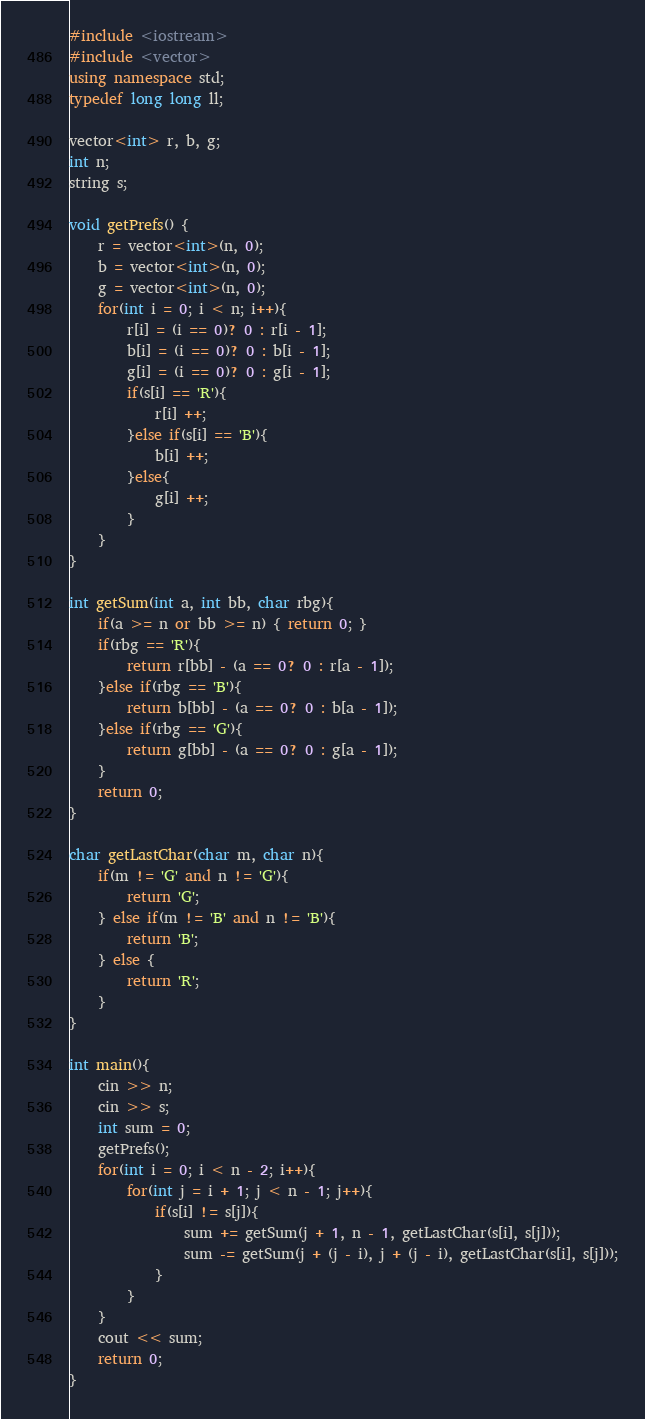<code> <loc_0><loc_0><loc_500><loc_500><_C++_>#include <iostream>
#include <vector>
using namespace std;
typedef long long ll;

vector<int> r, b, g;
int n;
string s;

void getPrefs() {
	r = vector<int>(n, 0);
	b = vector<int>(n, 0);
	g = vector<int>(n, 0);
	for(int i = 0; i < n; i++){
		r[i] = (i == 0)? 0 : r[i - 1];
		b[i] = (i == 0)? 0 : b[i - 1];
		g[i] = (i == 0)? 0 : g[i - 1];
		if(s[i] == 'R'){
			r[i] ++;
		}else if(s[i] == 'B'){
			b[i] ++;
		}else{
			g[i] ++;
		}
	}
}

int getSum(int a, int bb, char rbg){
	if(a >= n or bb >= n) { return 0; }
	if(rbg == 'R'){
		return r[bb] - (a == 0? 0 : r[a - 1]);
	}else if(rbg == 'B'){
		return b[bb] - (a == 0? 0 : b[a - 1]);
	}else if(rbg == 'G'){
		return g[bb] - (a == 0? 0 : g[a - 1]);
	}
	return 0;
}

char getLastChar(char m, char n){
	if(m != 'G' and n != 'G'){
		return 'G';
	} else if(m != 'B' and n != 'B'){
		return 'B';
	} else {
		return 'R';
	}
}

int main(){
	cin >> n;
	cin >> s;
	int sum = 0;
	getPrefs();
	for(int i = 0; i < n - 2; i++){
		for(int j = i + 1; j < n - 1; j++){
			if(s[i] != s[j]){
				sum += getSum(j + 1, n - 1, getLastChar(s[i], s[j]));
				sum -= getSum(j + (j - i), j + (j - i), getLastChar(s[i], s[j]));
			}
		}
	}
	cout << sum;
	return 0;
}</code> 